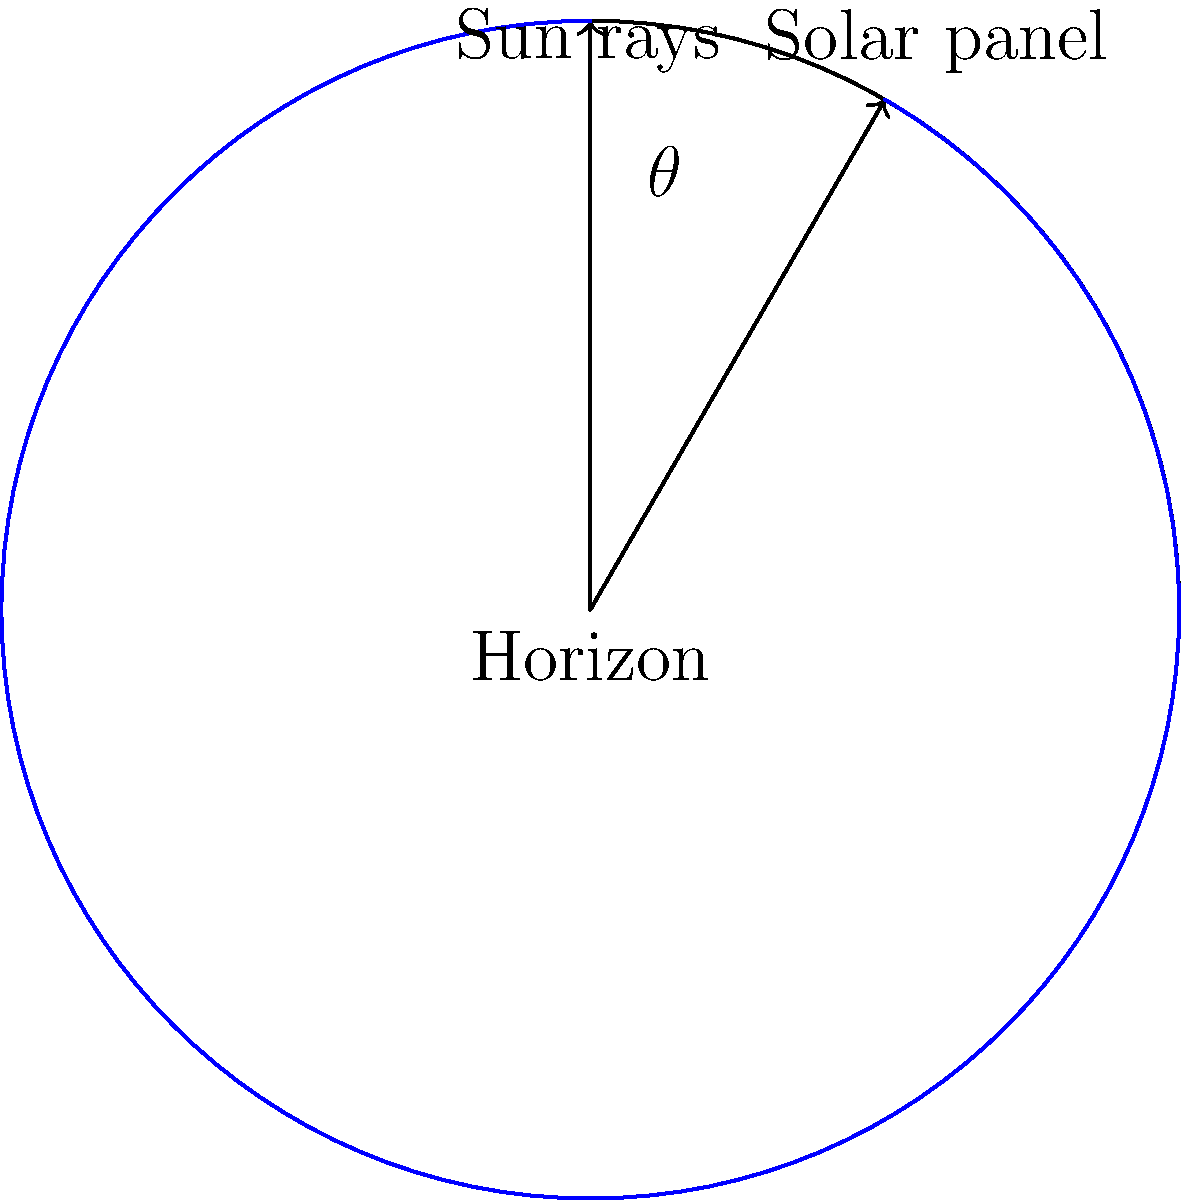Calculate the optimal tilt angle $\theta$ for a solar panel in a location with latitude $\phi = 40°N$. Assume the panel should be optimized for the equinox when the sun's declination angle $\delta = 0°$. Use the formula: $\theta = \phi - \delta + 15°$, where the additional 15° is added to account for atmospheric refraction and to optimize for winter months. To calculate the optimal tilt angle $\theta$ for the solar panel, we'll use the given formula and information:

1. Formula: $\theta = \phi - \delta + 15°$
2. Given: 
   - Latitude $\phi = 40°N$
   - Sun's declination angle $\delta = 0°$ (at equinox)
   - Additional 15° for atmospheric refraction and winter optimization

Step 1: Substitute the known values into the formula.
$\theta = 40° - 0° + 15°$

Step 2: Perform the calculation.
$\theta = 40° + 15° = 55°$

Therefore, the optimal tilt angle for the solar panel at the given location during the equinox is 55°.
Answer: $55°$ 